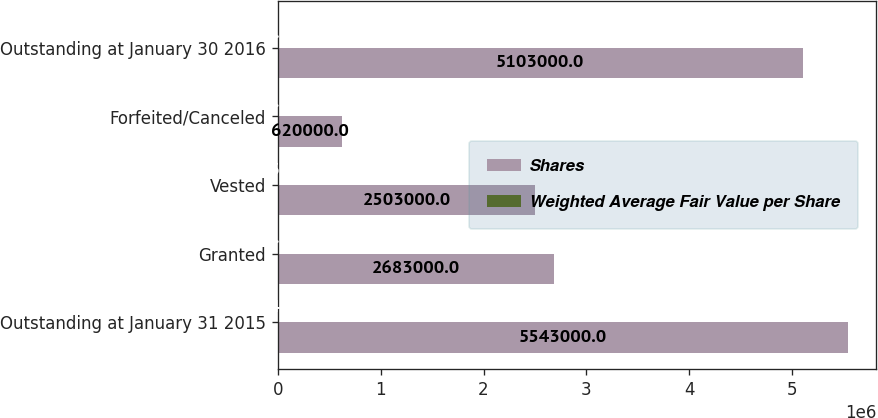<chart> <loc_0><loc_0><loc_500><loc_500><stacked_bar_chart><ecel><fcel>Outstanding at January 31 2015<fcel>Granted<fcel>Vested<fcel>Forfeited/Canceled<fcel>Outstanding at January 30 2016<nl><fcel>Shares<fcel>5.543e+06<fcel>2.683e+06<fcel>2.503e+06<fcel>620000<fcel>5.103e+06<nl><fcel>Weighted Average Fair Value per Share<fcel>24.4<fcel>38.72<fcel>23.1<fcel>29.98<fcel>31.89<nl></chart> 